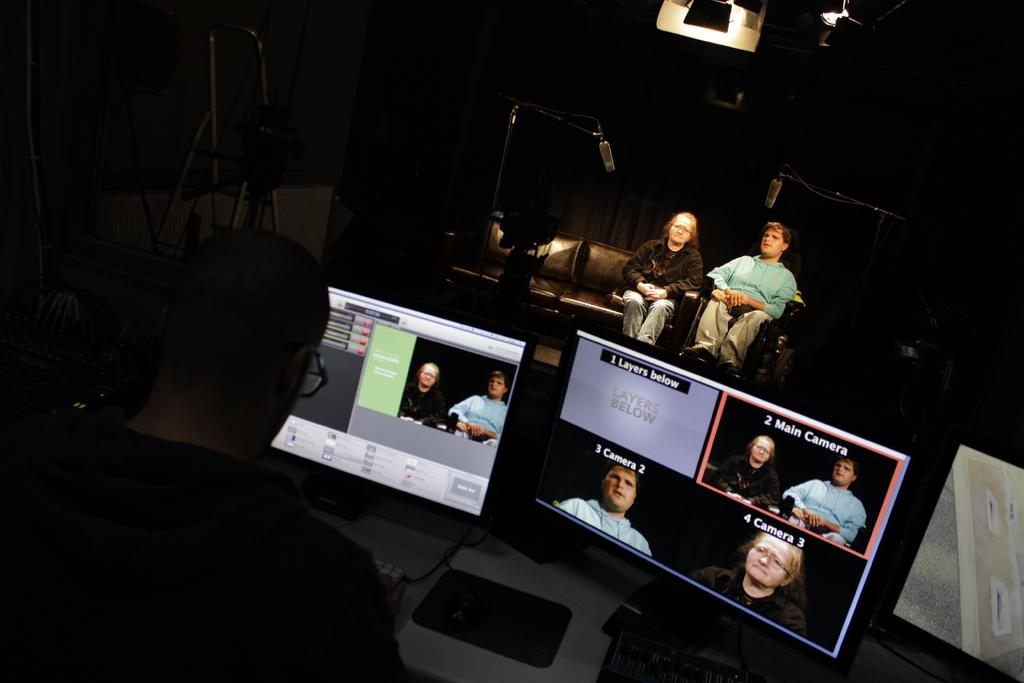Provide a one-sentence caption for the provided image. A computer screen shows several different camera views, including main camera, camera 2, and camera 3. 